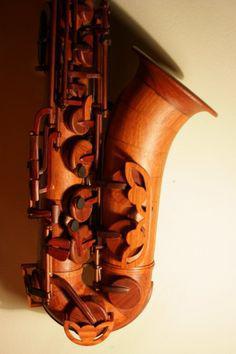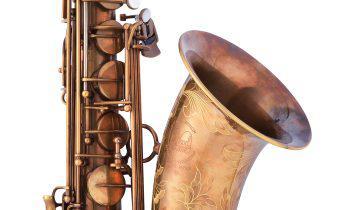The first image is the image on the left, the second image is the image on the right. Assess this claim about the two images: "The entire instrument is visible in every image.". Correct or not? Answer yes or no. No. 